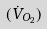Convert formula to latex. <formula><loc_0><loc_0><loc_500><loc_500>( \dot { V } _ { O _ { 2 } } )</formula> 